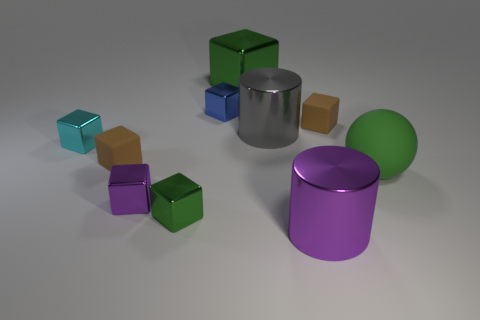Subtract 3 cubes. How many cubes are left? 4 Subtract all green cubes. How many cubes are left? 5 Subtract all small blue blocks. How many blocks are left? 6 Subtract all purple cubes. Subtract all yellow cylinders. How many cubes are left? 6 Subtract all cubes. How many objects are left? 3 Add 2 small blue things. How many small blue things are left? 3 Add 1 large blue rubber cylinders. How many large blue rubber cylinders exist? 1 Subtract 1 gray cylinders. How many objects are left? 9 Subtract all cyan cubes. Subtract all small brown rubber blocks. How many objects are left? 7 